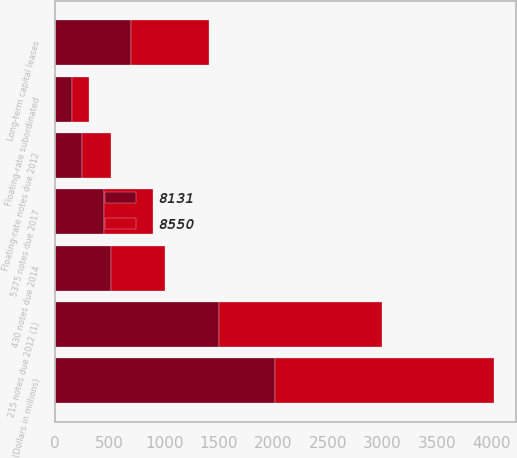<chart> <loc_0><loc_0><loc_500><loc_500><stacked_bar_chart><ecel><fcel>(Dollars in millions)<fcel>Floating-rate subordinated<fcel>215 notes due 2012 (1)<fcel>Long-term capital leases<fcel>430 notes due 2014<fcel>5375 notes due 2017<fcel>Floating-rate notes due 2012<nl><fcel>8131<fcel>2011<fcel>155<fcel>1500<fcel>694<fcel>512<fcel>450<fcel>250<nl><fcel>8550<fcel>2010<fcel>155<fcel>1499<fcel>716<fcel>500<fcel>450<fcel>268<nl></chart> 